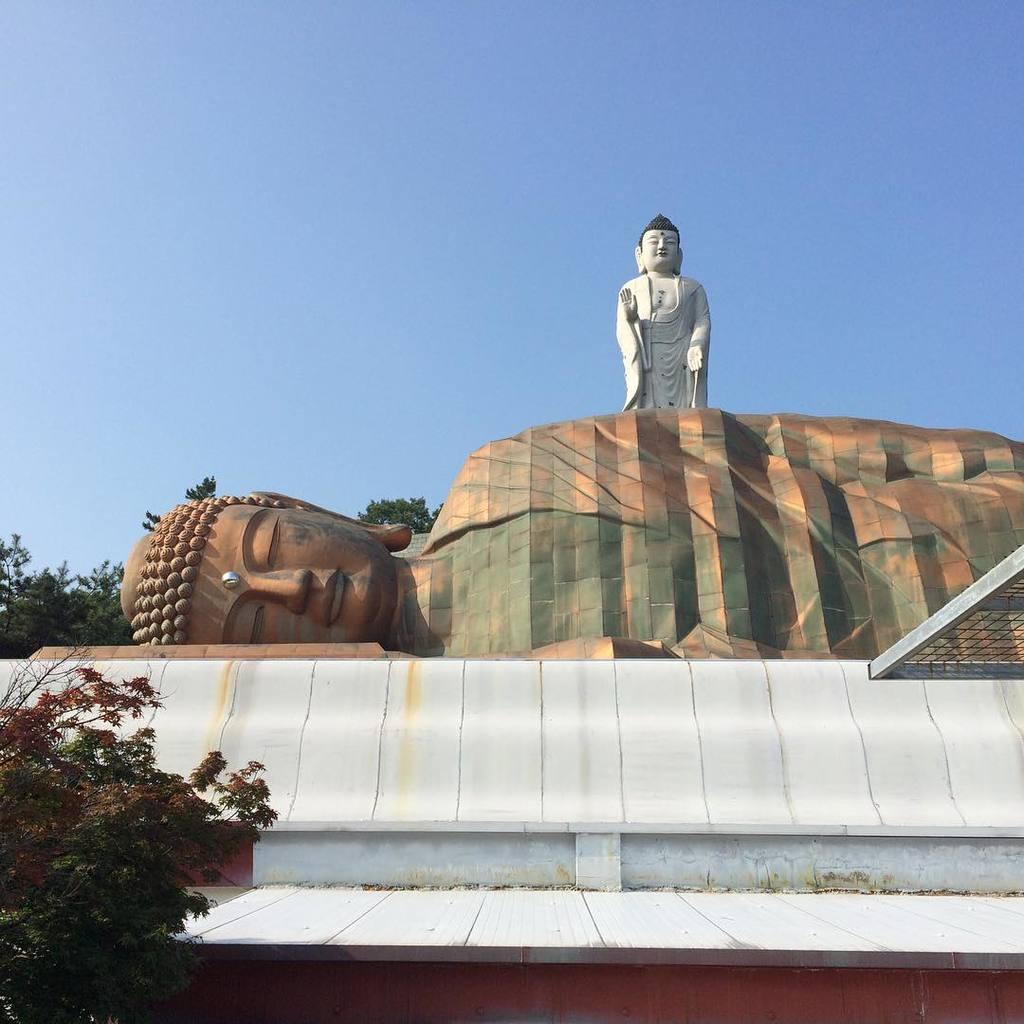How many sculptures are present in the image? There are two sculptures in the image. What are the subjects of the sculptures? One of the sculptures is a sleeping Buddha, and the other is a standing Buddha. What can be seen in the background of the image? Trees are visible in the image. What type of business is being conducted in the image? There is no indication of any business being conducted in the image; it primarily features the two sculptures and the trees in the background. 